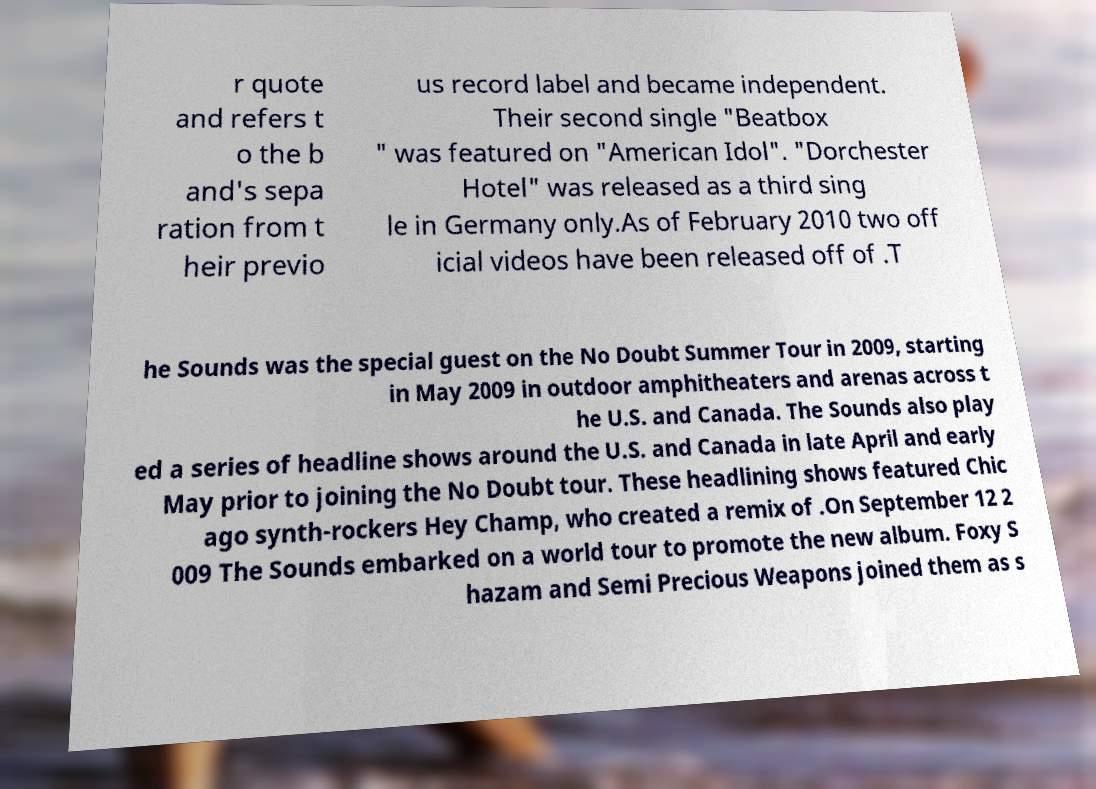Please read and relay the text visible in this image. What does it say? r quote and refers t o the b and's sepa ration from t heir previo us record label and became independent. Their second single "Beatbox " was featured on "American Idol". "Dorchester Hotel" was released as a third sing le in Germany only.As of February 2010 two off icial videos have been released off of .T he Sounds was the special guest on the No Doubt Summer Tour in 2009, starting in May 2009 in outdoor amphitheaters and arenas across t he U.S. and Canada. The Sounds also play ed a series of headline shows around the U.S. and Canada in late April and early May prior to joining the No Doubt tour. These headlining shows featured Chic ago synth-rockers Hey Champ, who created a remix of .On September 12 2 009 The Sounds embarked on a world tour to promote the new album. Foxy S hazam and Semi Precious Weapons joined them as s 